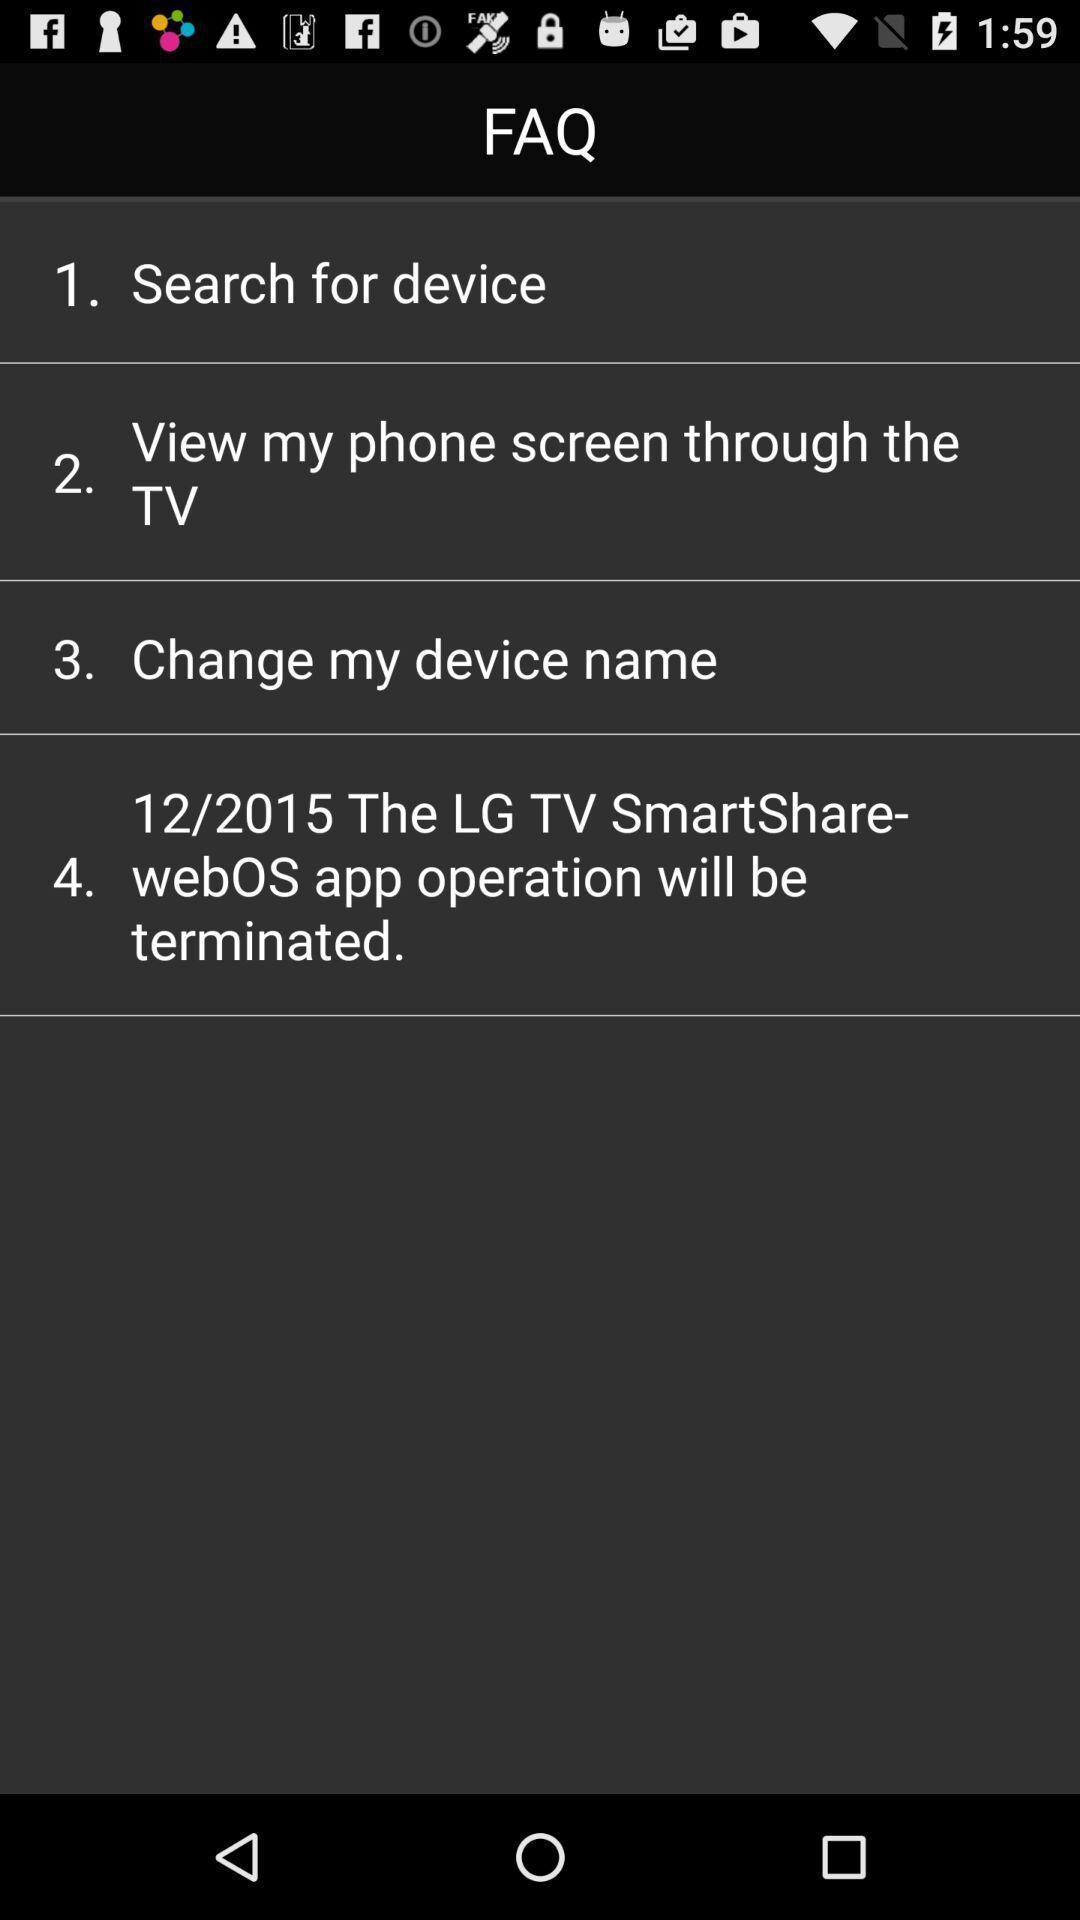Describe the visual elements of this screenshot. Screen showing faq about the smart tv. 